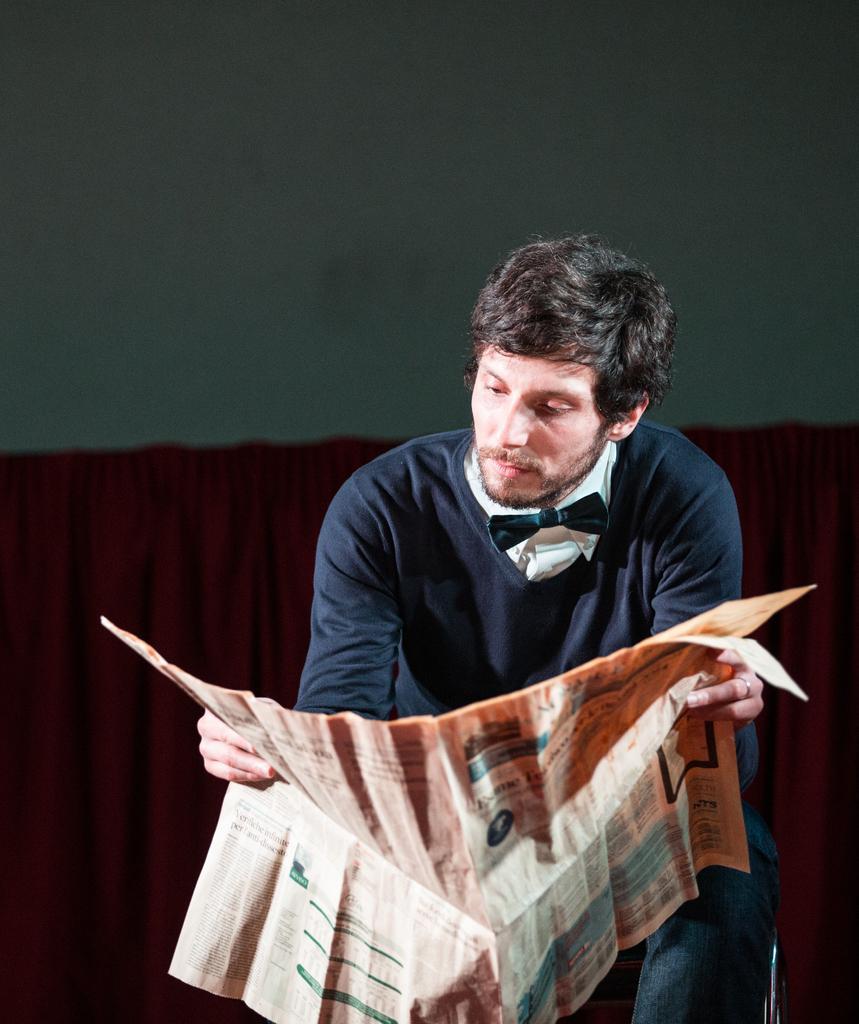Could you give a brief overview of what you see in this image? In the center of the image a man is sitting on a chair and holding a newspaper. In the middle of the image curtain is present. At the top of the image wall is there. 